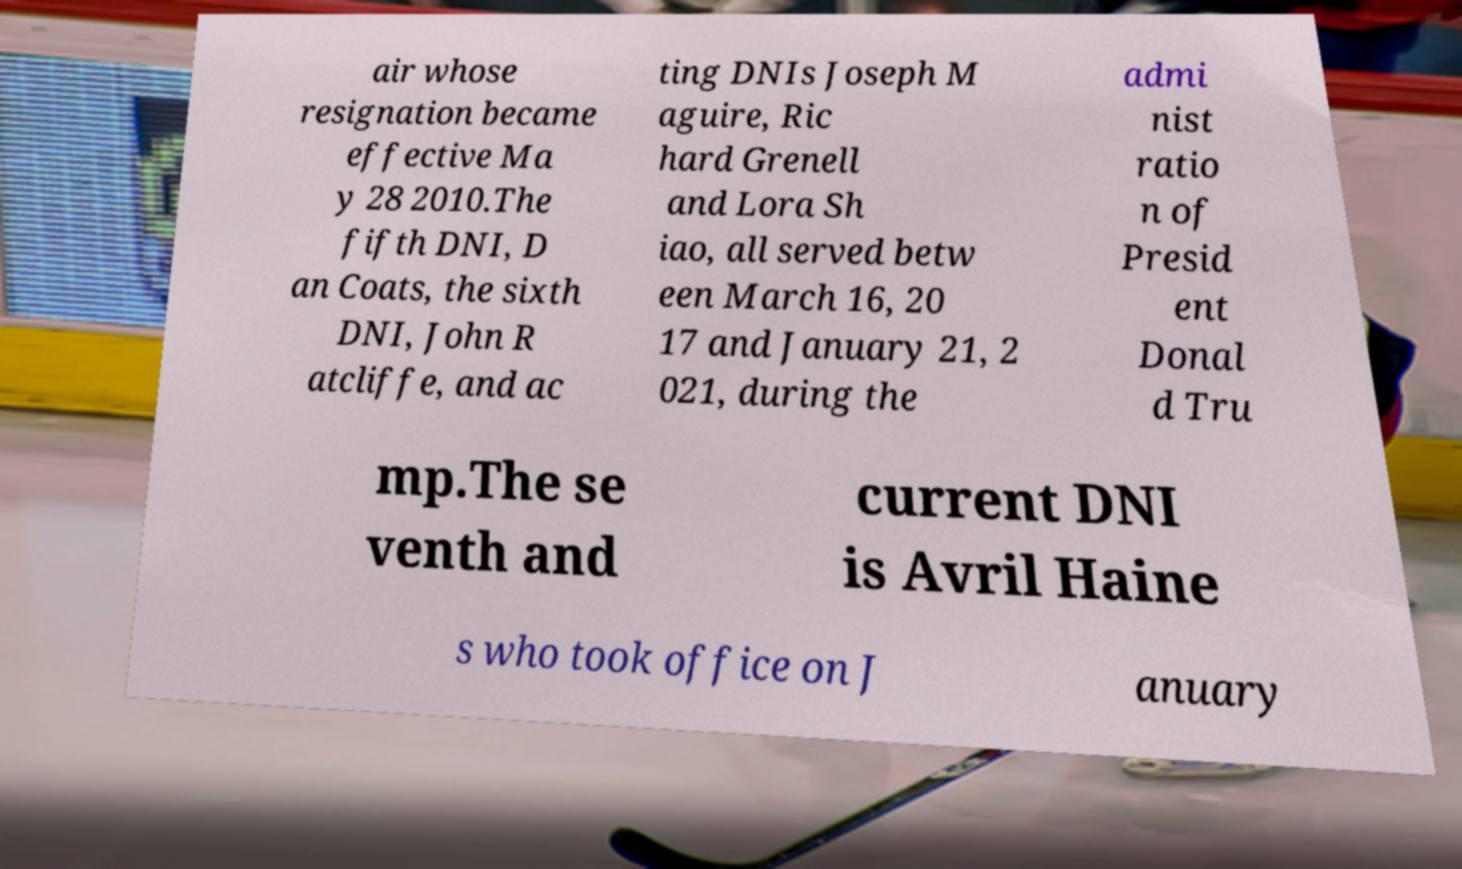Could you extract and type out the text from this image? air whose resignation became effective Ma y 28 2010.The fifth DNI, D an Coats, the sixth DNI, John R atcliffe, and ac ting DNIs Joseph M aguire, Ric hard Grenell and Lora Sh iao, all served betw een March 16, 20 17 and January 21, 2 021, during the admi nist ratio n of Presid ent Donal d Tru mp.The se venth and current DNI is Avril Haine s who took office on J anuary 